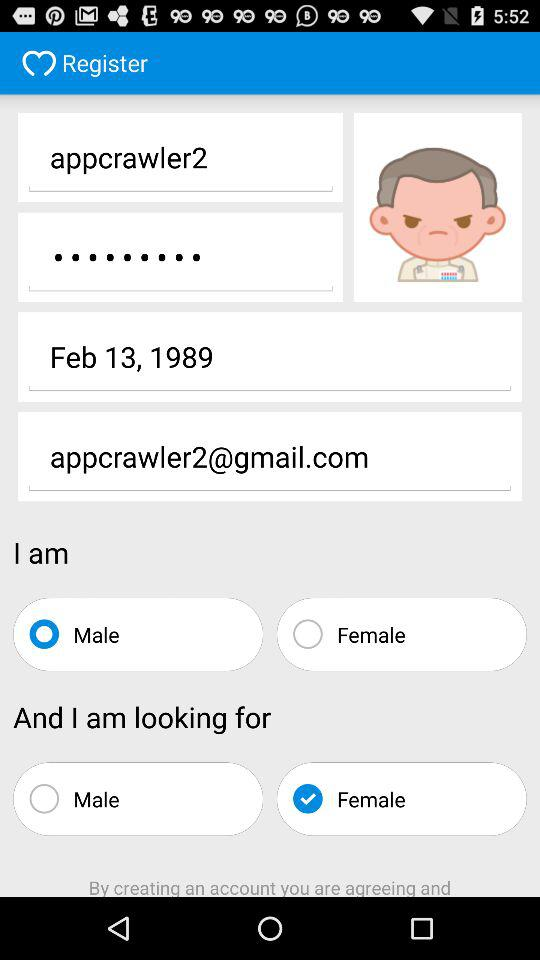What is the user name? The user name is "appcrawler2". 